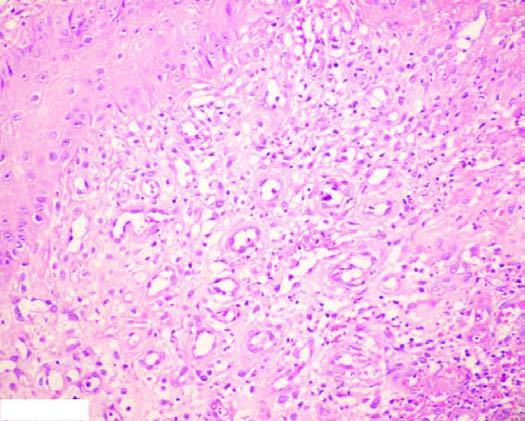what has inflammatory cell infiltrate, newly formed blood vessels and young fibrous tissue in loose matrix?
Answer the question using a single word or phrase. Active granulation tissue 